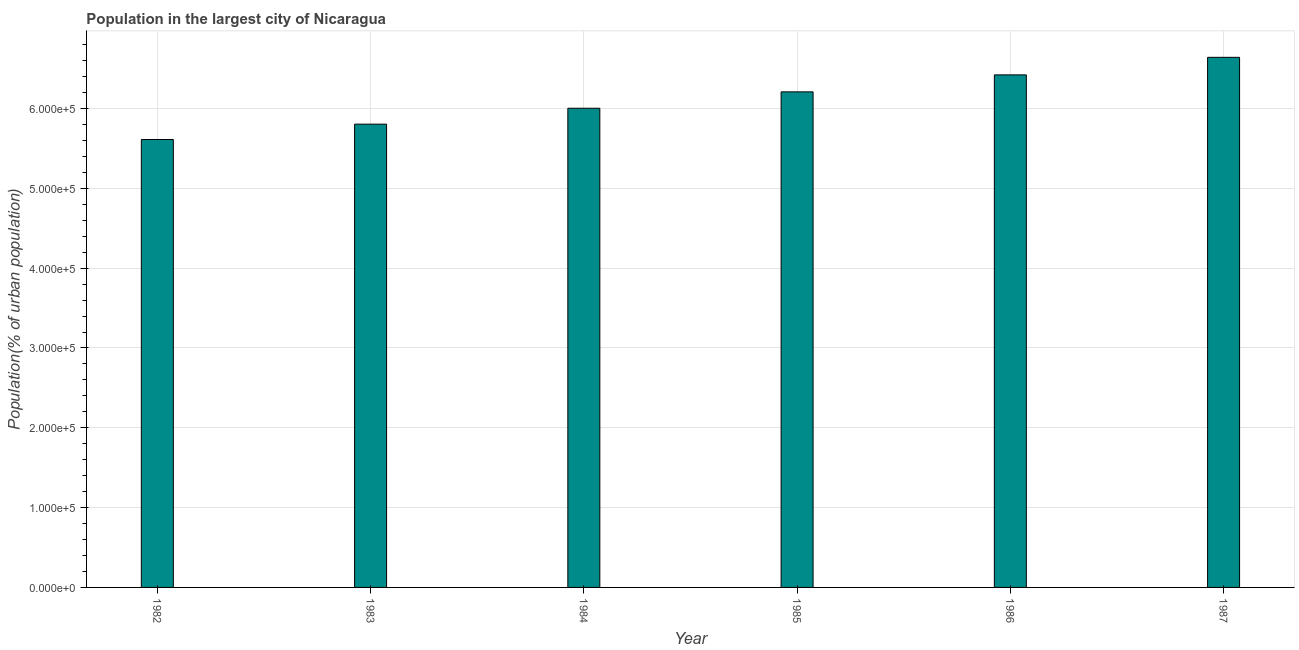Does the graph contain any zero values?
Your answer should be very brief. No. Does the graph contain grids?
Provide a short and direct response. Yes. What is the title of the graph?
Give a very brief answer. Population in the largest city of Nicaragua. What is the label or title of the Y-axis?
Ensure brevity in your answer.  Population(% of urban population). What is the population in largest city in 1986?
Provide a short and direct response. 6.42e+05. Across all years, what is the maximum population in largest city?
Offer a terse response. 6.64e+05. Across all years, what is the minimum population in largest city?
Keep it short and to the point. 5.61e+05. In which year was the population in largest city minimum?
Give a very brief answer. 1982. What is the sum of the population in largest city?
Provide a succinct answer. 3.67e+06. What is the difference between the population in largest city in 1984 and 1986?
Make the answer very short. -4.18e+04. What is the average population in largest city per year?
Your answer should be very brief. 6.12e+05. What is the median population in largest city?
Provide a short and direct response. 6.11e+05. In how many years, is the population in largest city greater than 600000 %?
Provide a succinct answer. 4. What is the ratio of the population in largest city in 1983 to that in 1986?
Your answer should be very brief. 0.9. Is the difference between the population in largest city in 1984 and 1987 greater than the difference between any two years?
Provide a short and direct response. No. What is the difference between the highest and the second highest population in largest city?
Your answer should be compact. 2.20e+04. What is the difference between the highest and the lowest population in largest city?
Your response must be concise. 1.03e+05. In how many years, is the population in largest city greater than the average population in largest city taken over all years?
Keep it short and to the point. 3. Are all the bars in the graph horizontal?
Offer a very short reply. No. Are the values on the major ticks of Y-axis written in scientific E-notation?
Make the answer very short. Yes. What is the Population(% of urban population) in 1982?
Provide a succinct answer. 5.61e+05. What is the Population(% of urban population) in 1983?
Provide a succinct answer. 5.80e+05. What is the Population(% of urban population) in 1984?
Your answer should be compact. 6.00e+05. What is the Population(% of urban population) of 1985?
Offer a very short reply. 6.21e+05. What is the Population(% of urban population) in 1986?
Keep it short and to the point. 6.42e+05. What is the Population(% of urban population) in 1987?
Offer a very short reply. 6.64e+05. What is the difference between the Population(% of urban population) in 1982 and 1983?
Give a very brief answer. -1.92e+04. What is the difference between the Population(% of urban population) in 1982 and 1984?
Your response must be concise. -3.91e+04. What is the difference between the Population(% of urban population) in 1982 and 1985?
Provide a short and direct response. -5.97e+04. What is the difference between the Population(% of urban population) in 1982 and 1986?
Keep it short and to the point. -8.09e+04. What is the difference between the Population(% of urban population) in 1982 and 1987?
Keep it short and to the point. -1.03e+05. What is the difference between the Population(% of urban population) in 1983 and 1984?
Keep it short and to the point. -1.99e+04. What is the difference between the Population(% of urban population) in 1983 and 1985?
Provide a succinct answer. -4.04e+04. What is the difference between the Population(% of urban population) in 1983 and 1986?
Ensure brevity in your answer.  -6.17e+04. What is the difference between the Population(% of urban population) in 1983 and 1987?
Provide a short and direct response. -8.37e+04. What is the difference between the Population(% of urban population) in 1984 and 1985?
Offer a terse response. -2.05e+04. What is the difference between the Population(% of urban population) in 1984 and 1986?
Offer a terse response. -4.18e+04. What is the difference between the Population(% of urban population) in 1984 and 1987?
Ensure brevity in your answer.  -6.38e+04. What is the difference between the Population(% of urban population) in 1985 and 1986?
Offer a very short reply. -2.13e+04. What is the difference between the Population(% of urban population) in 1985 and 1987?
Give a very brief answer. -4.33e+04. What is the difference between the Population(% of urban population) in 1986 and 1987?
Your answer should be compact. -2.20e+04. What is the ratio of the Population(% of urban population) in 1982 to that in 1983?
Offer a very short reply. 0.97. What is the ratio of the Population(% of urban population) in 1982 to that in 1984?
Make the answer very short. 0.94. What is the ratio of the Population(% of urban population) in 1982 to that in 1985?
Offer a very short reply. 0.9. What is the ratio of the Population(% of urban population) in 1982 to that in 1986?
Your answer should be compact. 0.87. What is the ratio of the Population(% of urban population) in 1982 to that in 1987?
Make the answer very short. 0.84. What is the ratio of the Population(% of urban population) in 1983 to that in 1984?
Your answer should be compact. 0.97. What is the ratio of the Population(% of urban population) in 1983 to that in 1985?
Provide a short and direct response. 0.94. What is the ratio of the Population(% of urban population) in 1983 to that in 1986?
Offer a terse response. 0.9. What is the ratio of the Population(% of urban population) in 1983 to that in 1987?
Provide a short and direct response. 0.87. What is the ratio of the Population(% of urban population) in 1984 to that in 1985?
Keep it short and to the point. 0.97. What is the ratio of the Population(% of urban population) in 1984 to that in 1986?
Your response must be concise. 0.94. What is the ratio of the Population(% of urban population) in 1984 to that in 1987?
Provide a succinct answer. 0.9. What is the ratio of the Population(% of urban population) in 1985 to that in 1986?
Provide a succinct answer. 0.97. What is the ratio of the Population(% of urban population) in 1985 to that in 1987?
Provide a short and direct response. 0.94. 